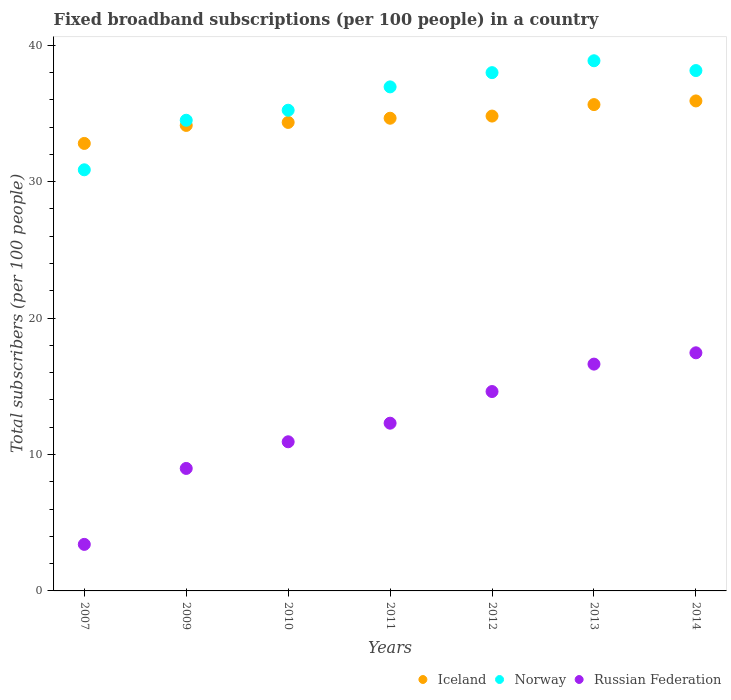What is the number of broadband subscriptions in Russian Federation in 2011?
Make the answer very short. 12.29. Across all years, what is the maximum number of broadband subscriptions in Russian Federation?
Keep it short and to the point. 17.45. Across all years, what is the minimum number of broadband subscriptions in Iceland?
Offer a very short reply. 32.8. In which year was the number of broadband subscriptions in Russian Federation minimum?
Give a very brief answer. 2007. What is the total number of broadband subscriptions in Russian Federation in the graph?
Ensure brevity in your answer.  84.31. What is the difference between the number of broadband subscriptions in Russian Federation in 2011 and that in 2014?
Your answer should be compact. -5.16. What is the difference between the number of broadband subscriptions in Iceland in 2011 and the number of broadband subscriptions in Norway in 2010?
Ensure brevity in your answer.  -0.59. What is the average number of broadband subscriptions in Norway per year?
Your answer should be very brief. 36.08. In the year 2012, what is the difference between the number of broadband subscriptions in Iceland and number of broadband subscriptions in Norway?
Your answer should be very brief. -3.18. In how many years, is the number of broadband subscriptions in Norway greater than 22?
Ensure brevity in your answer.  7. What is the ratio of the number of broadband subscriptions in Iceland in 2010 to that in 2012?
Give a very brief answer. 0.99. What is the difference between the highest and the second highest number of broadband subscriptions in Norway?
Offer a terse response. 0.72. What is the difference between the highest and the lowest number of broadband subscriptions in Russian Federation?
Provide a short and direct response. 14.04. Is the sum of the number of broadband subscriptions in Iceland in 2007 and 2014 greater than the maximum number of broadband subscriptions in Russian Federation across all years?
Offer a very short reply. Yes. Is the number of broadband subscriptions in Iceland strictly greater than the number of broadband subscriptions in Russian Federation over the years?
Your answer should be very brief. Yes. Is the number of broadband subscriptions in Russian Federation strictly less than the number of broadband subscriptions in Iceland over the years?
Provide a short and direct response. Yes. How many dotlines are there?
Provide a short and direct response. 3. What is the difference between two consecutive major ticks on the Y-axis?
Offer a terse response. 10. Does the graph contain grids?
Provide a succinct answer. No. Where does the legend appear in the graph?
Your response must be concise. Bottom right. How many legend labels are there?
Keep it short and to the point. 3. What is the title of the graph?
Keep it short and to the point. Fixed broadband subscriptions (per 100 people) in a country. What is the label or title of the Y-axis?
Offer a very short reply. Total subscribers (per 100 people). What is the Total subscribers (per 100 people) in Iceland in 2007?
Ensure brevity in your answer.  32.8. What is the Total subscribers (per 100 people) of Norway in 2007?
Your response must be concise. 30.87. What is the Total subscribers (per 100 people) of Russian Federation in 2007?
Provide a succinct answer. 3.41. What is the Total subscribers (per 100 people) of Iceland in 2009?
Provide a short and direct response. 34.12. What is the Total subscribers (per 100 people) of Norway in 2009?
Your answer should be compact. 34.5. What is the Total subscribers (per 100 people) of Russian Federation in 2009?
Make the answer very short. 8.98. What is the Total subscribers (per 100 people) in Iceland in 2010?
Your response must be concise. 34.34. What is the Total subscribers (per 100 people) of Norway in 2010?
Ensure brevity in your answer.  35.23. What is the Total subscribers (per 100 people) of Russian Federation in 2010?
Keep it short and to the point. 10.93. What is the Total subscribers (per 100 people) of Iceland in 2011?
Provide a succinct answer. 34.65. What is the Total subscribers (per 100 people) of Norway in 2011?
Keep it short and to the point. 36.94. What is the Total subscribers (per 100 people) of Russian Federation in 2011?
Give a very brief answer. 12.29. What is the Total subscribers (per 100 people) in Iceland in 2012?
Provide a short and direct response. 34.81. What is the Total subscribers (per 100 people) of Norway in 2012?
Give a very brief answer. 37.99. What is the Total subscribers (per 100 people) in Russian Federation in 2012?
Your answer should be compact. 14.61. What is the Total subscribers (per 100 people) of Iceland in 2013?
Offer a terse response. 35.65. What is the Total subscribers (per 100 people) of Norway in 2013?
Provide a succinct answer. 38.86. What is the Total subscribers (per 100 people) of Russian Federation in 2013?
Provide a short and direct response. 16.62. What is the Total subscribers (per 100 people) of Iceland in 2014?
Your answer should be compact. 35.92. What is the Total subscribers (per 100 people) of Norway in 2014?
Your response must be concise. 38.14. What is the Total subscribers (per 100 people) of Russian Federation in 2014?
Provide a succinct answer. 17.45. Across all years, what is the maximum Total subscribers (per 100 people) of Iceland?
Make the answer very short. 35.92. Across all years, what is the maximum Total subscribers (per 100 people) in Norway?
Offer a very short reply. 38.86. Across all years, what is the maximum Total subscribers (per 100 people) of Russian Federation?
Make the answer very short. 17.45. Across all years, what is the minimum Total subscribers (per 100 people) in Iceland?
Your answer should be very brief. 32.8. Across all years, what is the minimum Total subscribers (per 100 people) in Norway?
Your response must be concise. 30.87. Across all years, what is the minimum Total subscribers (per 100 people) of Russian Federation?
Offer a terse response. 3.41. What is the total Total subscribers (per 100 people) of Iceland in the graph?
Your response must be concise. 242.27. What is the total Total subscribers (per 100 people) of Norway in the graph?
Ensure brevity in your answer.  252.53. What is the total Total subscribers (per 100 people) in Russian Federation in the graph?
Your response must be concise. 84.31. What is the difference between the Total subscribers (per 100 people) in Iceland in 2007 and that in 2009?
Give a very brief answer. -1.32. What is the difference between the Total subscribers (per 100 people) in Norway in 2007 and that in 2009?
Your answer should be very brief. -3.63. What is the difference between the Total subscribers (per 100 people) of Russian Federation in 2007 and that in 2009?
Give a very brief answer. -5.57. What is the difference between the Total subscribers (per 100 people) of Iceland in 2007 and that in 2010?
Make the answer very short. -1.54. What is the difference between the Total subscribers (per 100 people) of Norway in 2007 and that in 2010?
Your answer should be very brief. -4.37. What is the difference between the Total subscribers (per 100 people) of Russian Federation in 2007 and that in 2010?
Your response must be concise. -7.52. What is the difference between the Total subscribers (per 100 people) of Iceland in 2007 and that in 2011?
Provide a short and direct response. -1.85. What is the difference between the Total subscribers (per 100 people) in Norway in 2007 and that in 2011?
Give a very brief answer. -6.08. What is the difference between the Total subscribers (per 100 people) in Russian Federation in 2007 and that in 2011?
Give a very brief answer. -8.88. What is the difference between the Total subscribers (per 100 people) of Iceland in 2007 and that in 2012?
Ensure brevity in your answer.  -2.01. What is the difference between the Total subscribers (per 100 people) of Norway in 2007 and that in 2012?
Provide a short and direct response. -7.12. What is the difference between the Total subscribers (per 100 people) in Russian Federation in 2007 and that in 2012?
Provide a succinct answer. -11.2. What is the difference between the Total subscribers (per 100 people) of Iceland in 2007 and that in 2013?
Keep it short and to the point. -2.85. What is the difference between the Total subscribers (per 100 people) of Norway in 2007 and that in 2013?
Provide a short and direct response. -7.99. What is the difference between the Total subscribers (per 100 people) in Russian Federation in 2007 and that in 2013?
Your answer should be very brief. -13.21. What is the difference between the Total subscribers (per 100 people) in Iceland in 2007 and that in 2014?
Offer a terse response. -3.12. What is the difference between the Total subscribers (per 100 people) in Norway in 2007 and that in 2014?
Keep it short and to the point. -7.27. What is the difference between the Total subscribers (per 100 people) of Russian Federation in 2007 and that in 2014?
Your answer should be very brief. -14.04. What is the difference between the Total subscribers (per 100 people) in Iceland in 2009 and that in 2010?
Your response must be concise. -0.22. What is the difference between the Total subscribers (per 100 people) of Norway in 2009 and that in 2010?
Provide a succinct answer. -0.73. What is the difference between the Total subscribers (per 100 people) in Russian Federation in 2009 and that in 2010?
Provide a succinct answer. -1.95. What is the difference between the Total subscribers (per 100 people) of Iceland in 2009 and that in 2011?
Your response must be concise. -0.53. What is the difference between the Total subscribers (per 100 people) in Norway in 2009 and that in 2011?
Make the answer very short. -2.45. What is the difference between the Total subscribers (per 100 people) in Russian Federation in 2009 and that in 2011?
Offer a very short reply. -3.32. What is the difference between the Total subscribers (per 100 people) in Iceland in 2009 and that in 2012?
Offer a terse response. -0.68. What is the difference between the Total subscribers (per 100 people) of Norway in 2009 and that in 2012?
Your response must be concise. -3.49. What is the difference between the Total subscribers (per 100 people) in Russian Federation in 2009 and that in 2012?
Your answer should be compact. -5.64. What is the difference between the Total subscribers (per 100 people) of Iceland in 2009 and that in 2013?
Your answer should be very brief. -1.53. What is the difference between the Total subscribers (per 100 people) of Norway in 2009 and that in 2013?
Ensure brevity in your answer.  -4.36. What is the difference between the Total subscribers (per 100 people) in Russian Federation in 2009 and that in 2013?
Provide a succinct answer. -7.65. What is the difference between the Total subscribers (per 100 people) of Iceland in 2009 and that in 2014?
Ensure brevity in your answer.  -1.79. What is the difference between the Total subscribers (per 100 people) in Norway in 2009 and that in 2014?
Offer a terse response. -3.64. What is the difference between the Total subscribers (per 100 people) in Russian Federation in 2009 and that in 2014?
Give a very brief answer. -8.48. What is the difference between the Total subscribers (per 100 people) of Iceland in 2010 and that in 2011?
Offer a very short reply. -0.31. What is the difference between the Total subscribers (per 100 people) of Norway in 2010 and that in 2011?
Make the answer very short. -1.71. What is the difference between the Total subscribers (per 100 people) of Russian Federation in 2010 and that in 2011?
Provide a short and direct response. -1.36. What is the difference between the Total subscribers (per 100 people) in Iceland in 2010 and that in 2012?
Make the answer very short. -0.47. What is the difference between the Total subscribers (per 100 people) of Norway in 2010 and that in 2012?
Your answer should be compact. -2.75. What is the difference between the Total subscribers (per 100 people) of Russian Federation in 2010 and that in 2012?
Give a very brief answer. -3.68. What is the difference between the Total subscribers (per 100 people) of Iceland in 2010 and that in 2013?
Your answer should be compact. -1.31. What is the difference between the Total subscribers (per 100 people) in Norway in 2010 and that in 2013?
Make the answer very short. -3.63. What is the difference between the Total subscribers (per 100 people) in Russian Federation in 2010 and that in 2013?
Your answer should be very brief. -5.69. What is the difference between the Total subscribers (per 100 people) of Iceland in 2010 and that in 2014?
Provide a short and direct response. -1.58. What is the difference between the Total subscribers (per 100 people) of Norway in 2010 and that in 2014?
Provide a short and direct response. -2.91. What is the difference between the Total subscribers (per 100 people) of Russian Federation in 2010 and that in 2014?
Keep it short and to the point. -6.52. What is the difference between the Total subscribers (per 100 people) in Iceland in 2011 and that in 2012?
Provide a short and direct response. -0.16. What is the difference between the Total subscribers (per 100 people) of Norway in 2011 and that in 2012?
Keep it short and to the point. -1.04. What is the difference between the Total subscribers (per 100 people) of Russian Federation in 2011 and that in 2012?
Offer a very short reply. -2.32. What is the difference between the Total subscribers (per 100 people) in Iceland in 2011 and that in 2013?
Your response must be concise. -1. What is the difference between the Total subscribers (per 100 people) of Norway in 2011 and that in 2013?
Your response must be concise. -1.92. What is the difference between the Total subscribers (per 100 people) of Russian Federation in 2011 and that in 2013?
Your answer should be very brief. -4.33. What is the difference between the Total subscribers (per 100 people) in Iceland in 2011 and that in 2014?
Your answer should be compact. -1.27. What is the difference between the Total subscribers (per 100 people) in Norway in 2011 and that in 2014?
Provide a succinct answer. -1.2. What is the difference between the Total subscribers (per 100 people) of Russian Federation in 2011 and that in 2014?
Offer a terse response. -5.16. What is the difference between the Total subscribers (per 100 people) of Iceland in 2012 and that in 2013?
Provide a short and direct response. -0.84. What is the difference between the Total subscribers (per 100 people) in Norway in 2012 and that in 2013?
Keep it short and to the point. -0.87. What is the difference between the Total subscribers (per 100 people) in Russian Federation in 2012 and that in 2013?
Offer a very short reply. -2.01. What is the difference between the Total subscribers (per 100 people) in Iceland in 2012 and that in 2014?
Provide a succinct answer. -1.11. What is the difference between the Total subscribers (per 100 people) in Norway in 2012 and that in 2014?
Offer a terse response. -0.15. What is the difference between the Total subscribers (per 100 people) in Russian Federation in 2012 and that in 2014?
Ensure brevity in your answer.  -2.84. What is the difference between the Total subscribers (per 100 people) of Iceland in 2013 and that in 2014?
Your answer should be very brief. -0.27. What is the difference between the Total subscribers (per 100 people) of Norway in 2013 and that in 2014?
Ensure brevity in your answer.  0.72. What is the difference between the Total subscribers (per 100 people) in Russian Federation in 2013 and that in 2014?
Keep it short and to the point. -0.83. What is the difference between the Total subscribers (per 100 people) in Iceland in 2007 and the Total subscribers (per 100 people) in Norway in 2009?
Your answer should be compact. -1.7. What is the difference between the Total subscribers (per 100 people) in Iceland in 2007 and the Total subscribers (per 100 people) in Russian Federation in 2009?
Make the answer very short. 23.82. What is the difference between the Total subscribers (per 100 people) of Norway in 2007 and the Total subscribers (per 100 people) of Russian Federation in 2009?
Offer a terse response. 21.89. What is the difference between the Total subscribers (per 100 people) in Iceland in 2007 and the Total subscribers (per 100 people) in Norway in 2010?
Your response must be concise. -2.43. What is the difference between the Total subscribers (per 100 people) in Iceland in 2007 and the Total subscribers (per 100 people) in Russian Federation in 2010?
Ensure brevity in your answer.  21.87. What is the difference between the Total subscribers (per 100 people) in Norway in 2007 and the Total subscribers (per 100 people) in Russian Federation in 2010?
Offer a very short reply. 19.94. What is the difference between the Total subscribers (per 100 people) in Iceland in 2007 and the Total subscribers (per 100 people) in Norway in 2011?
Ensure brevity in your answer.  -4.14. What is the difference between the Total subscribers (per 100 people) in Iceland in 2007 and the Total subscribers (per 100 people) in Russian Federation in 2011?
Make the answer very short. 20.51. What is the difference between the Total subscribers (per 100 people) of Norway in 2007 and the Total subscribers (per 100 people) of Russian Federation in 2011?
Offer a terse response. 18.57. What is the difference between the Total subscribers (per 100 people) of Iceland in 2007 and the Total subscribers (per 100 people) of Norway in 2012?
Your answer should be very brief. -5.19. What is the difference between the Total subscribers (per 100 people) in Iceland in 2007 and the Total subscribers (per 100 people) in Russian Federation in 2012?
Provide a short and direct response. 18.19. What is the difference between the Total subscribers (per 100 people) of Norway in 2007 and the Total subscribers (per 100 people) of Russian Federation in 2012?
Offer a terse response. 16.25. What is the difference between the Total subscribers (per 100 people) in Iceland in 2007 and the Total subscribers (per 100 people) in Norway in 2013?
Make the answer very short. -6.06. What is the difference between the Total subscribers (per 100 people) in Iceland in 2007 and the Total subscribers (per 100 people) in Russian Federation in 2013?
Offer a very short reply. 16.18. What is the difference between the Total subscribers (per 100 people) of Norway in 2007 and the Total subscribers (per 100 people) of Russian Federation in 2013?
Your response must be concise. 14.24. What is the difference between the Total subscribers (per 100 people) of Iceland in 2007 and the Total subscribers (per 100 people) of Norway in 2014?
Offer a very short reply. -5.34. What is the difference between the Total subscribers (per 100 people) in Iceland in 2007 and the Total subscribers (per 100 people) in Russian Federation in 2014?
Offer a terse response. 15.35. What is the difference between the Total subscribers (per 100 people) of Norway in 2007 and the Total subscribers (per 100 people) of Russian Federation in 2014?
Ensure brevity in your answer.  13.41. What is the difference between the Total subscribers (per 100 people) in Iceland in 2009 and the Total subscribers (per 100 people) in Norway in 2010?
Make the answer very short. -1.11. What is the difference between the Total subscribers (per 100 people) of Iceland in 2009 and the Total subscribers (per 100 people) of Russian Federation in 2010?
Provide a short and direct response. 23.19. What is the difference between the Total subscribers (per 100 people) in Norway in 2009 and the Total subscribers (per 100 people) in Russian Federation in 2010?
Provide a short and direct response. 23.57. What is the difference between the Total subscribers (per 100 people) in Iceland in 2009 and the Total subscribers (per 100 people) in Norway in 2011?
Offer a very short reply. -2.82. What is the difference between the Total subscribers (per 100 people) in Iceland in 2009 and the Total subscribers (per 100 people) in Russian Federation in 2011?
Your answer should be very brief. 21.83. What is the difference between the Total subscribers (per 100 people) of Norway in 2009 and the Total subscribers (per 100 people) of Russian Federation in 2011?
Keep it short and to the point. 22.2. What is the difference between the Total subscribers (per 100 people) in Iceland in 2009 and the Total subscribers (per 100 people) in Norway in 2012?
Offer a very short reply. -3.87. What is the difference between the Total subscribers (per 100 people) of Iceland in 2009 and the Total subscribers (per 100 people) of Russian Federation in 2012?
Your answer should be very brief. 19.51. What is the difference between the Total subscribers (per 100 people) of Norway in 2009 and the Total subscribers (per 100 people) of Russian Federation in 2012?
Give a very brief answer. 19.88. What is the difference between the Total subscribers (per 100 people) of Iceland in 2009 and the Total subscribers (per 100 people) of Norway in 2013?
Your answer should be very brief. -4.74. What is the difference between the Total subscribers (per 100 people) of Iceland in 2009 and the Total subscribers (per 100 people) of Russian Federation in 2013?
Keep it short and to the point. 17.5. What is the difference between the Total subscribers (per 100 people) of Norway in 2009 and the Total subscribers (per 100 people) of Russian Federation in 2013?
Ensure brevity in your answer.  17.87. What is the difference between the Total subscribers (per 100 people) of Iceland in 2009 and the Total subscribers (per 100 people) of Norway in 2014?
Your answer should be compact. -4.02. What is the difference between the Total subscribers (per 100 people) of Iceland in 2009 and the Total subscribers (per 100 people) of Russian Federation in 2014?
Offer a very short reply. 16.67. What is the difference between the Total subscribers (per 100 people) of Norway in 2009 and the Total subscribers (per 100 people) of Russian Federation in 2014?
Your answer should be compact. 17.05. What is the difference between the Total subscribers (per 100 people) of Iceland in 2010 and the Total subscribers (per 100 people) of Norway in 2011?
Ensure brevity in your answer.  -2.61. What is the difference between the Total subscribers (per 100 people) of Iceland in 2010 and the Total subscribers (per 100 people) of Russian Federation in 2011?
Give a very brief answer. 22.04. What is the difference between the Total subscribers (per 100 people) of Norway in 2010 and the Total subscribers (per 100 people) of Russian Federation in 2011?
Your answer should be compact. 22.94. What is the difference between the Total subscribers (per 100 people) of Iceland in 2010 and the Total subscribers (per 100 people) of Norway in 2012?
Provide a short and direct response. -3.65. What is the difference between the Total subscribers (per 100 people) in Iceland in 2010 and the Total subscribers (per 100 people) in Russian Federation in 2012?
Give a very brief answer. 19.72. What is the difference between the Total subscribers (per 100 people) of Norway in 2010 and the Total subscribers (per 100 people) of Russian Federation in 2012?
Make the answer very short. 20.62. What is the difference between the Total subscribers (per 100 people) in Iceland in 2010 and the Total subscribers (per 100 people) in Norway in 2013?
Provide a succinct answer. -4.52. What is the difference between the Total subscribers (per 100 people) of Iceland in 2010 and the Total subscribers (per 100 people) of Russian Federation in 2013?
Provide a succinct answer. 17.71. What is the difference between the Total subscribers (per 100 people) in Norway in 2010 and the Total subscribers (per 100 people) in Russian Federation in 2013?
Offer a terse response. 18.61. What is the difference between the Total subscribers (per 100 people) in Iceland in 2010 and the Total subscribers (per 100 people) in Norway in 2014?
Give a very brief answer. -3.8. What is the difference between the Total subscribers (per 100 people) of Iceland in 2010 and the Total subscribers (per 100 people) of Russian Federation in 2014?
Ensure brevity in your answer.  16.89. What is the difference between the Total subscribers (per 100 people) of Norway in 2010 and the Total subscribers (per 100 people) of Russian Federation in 2014?
Keep it short and to the point. 17.78. What is the difference between the Total subscribers (per 100 people) in Iceland in 2011 and the Total subscribers (per 100 people) in Norway in 2012?
Your response must be concise. -3.34. What is the difference between the Total subscribers (per 100 people) of Iceland in 2011 and the Total subscribers (per 100 people) of Russian Federation in 2012?
Offer a very short reply. 20.03. What is the difference between the Total subscribers (per 100 people) of Norway in 2011 and the Total subscribers (per 100 people) of Russian Federation in 2012?
Your answer should be very brief. 22.33. What is the difference between the Total subscribers (per 100 people) of Iceland in 2011 and the Total subscribers (per 100 people) of Norway in 2013?
Ensure brevity in your answer.  -4.21. What is the difference between the Total subscribers (per 100 people) of Iceland in 2011 and the Total subscribers (per 100 people) of Russian Federation in 2013?
Offer a terse response. 18.02. What is the difference between the Total subscribers (per 100 people) in Norway in 2011 and the Total subscribers (per 100 people) in Russian Federation in 2013?
Give a very brief answer. 20.32. What is the difference between the Total subscribers (per 100 people) of Iceland in 2011 and the Total subscribers (per 100 people) of Norway in 2014?
Offer a very short reply. -3.49. What is the difference between the Total subscribers (per 100 people) of Iceland in 2011 and the Total subscribers (per 100 people) of Russian Federation in 2014?
Provide a succinct answer. 17.19. What is the difference between the Total subscribers (per 100 people) of Norway in 2011 and the Total subscribers (per 100 people) of Russian Federation in 2014?
Offer a very short reply. 19.49. What is the difference between the Total subscribers (per 100 people) of Iceland in 2012 and the Total subscribers (per 100 people) of Norway in 2013?
Your answer should be compact. -4.05. What is the difference between the Total subscribers (per 100 people) in Iceland in 2012 and the Total subscribers (per 100 people) in Russian Federation in 2013?
Provide a succinct answer. 18.18. What is the difference between the Total subscribers (per 100 people) of Norway in 2012 and the Total subscribers (per 100 people) of Russian Federation in 2013?
Ensure brevity in your answer.  21.36. What is the difference between the Total subscribers (per 100 people) in Iceland in 2012 and the Total subscribers (per 100 people) in Norway in 2014?
Your answer should be compact. -3.34. What is the difference between the Total subscribers (per 100 people) of Iceland in 2012 and the Total subscribers (per 100 people) of Russian Federation in 2014?
Offer a very short reply. 17.35. What is the difference between the Total subscribers (per 100 people) in Norway in 2012 and the Total subscribers (per 100 people) in Russian Federation in 2014?
Your answer should be compact. 20.54. What is the difference between the Total subscribers (per 100 people) in Iceland in 2013 and the Total subscribers (per 100 people) in Norway in 2014?
Offer a very short reply. -2.5. What is the difference between the Total subscribers (per 100 people) in Iceland in 2013 and the Total subscribers (per 100 people) in Russian Federation in 2014?
Keep it short and to the point. 18.19. What is the difference between the Total subscribers (per 100 people) of Norway in 2013 and the Total subscribers (per 100 people) of Russian Federation in 2014?
Your answer should be very brief. 21.41. What is the average Total subscribers (per 100 people) of Iceland per year?
Give a very brief answer. 34.61. What is the average Total subscribers (per 100 people) of Norway per year?
Ensure brevity in your answer.  36.08. What is the average Total subscribers (per 100 people) in Russian Federation per year?
Provide a short and direct response. 12.04. In the year 2007, what is the difference between the Total subscribers (per 100 people) in Iceland and Total subscribers (per 100 people) in Norway?
Keep it short and to the point. 1.93. In the year 2007, what is the difference between the Total subscribers (per 100 people) of Iceland and Total subscribers (per 100 people) of Russian Federation?
Make the answer very short. 29.39. In the year 2007, what is the difference between the Total subscribers (per 100 people) in Norway and Total subscribers (per 100 people) in Russian Federation?
Give a very brief answer. 27.46. In the year 2009, what is the difference between the Total subscribers (per 100 people) in Iceland and Total subscribers (per 100 people) in Norway?
Provide a short and direct response. -0.38. In the year 2009, what is the difference between the Total subscribers (per 100 people) in Iceland and Total subscribers (per 100 people) in Russian Federation?
Ensure brevity in your answer.  25.14. In the year 2009, what is the difference between the Total subscribers (per 100 people) in Norway and Total subscribers (per 100 people) in Russian Federation?
Your answer should be compact. 25.52. In the year 2010, what is the difference between the Total subscribers (per 100 people) of Iceland and Total subscribers (per 100 people) of Norway?
Your answer should be compact. -0.89. In the year 2010, what is the difference between the Total subscribers (per 100 people) in Iceland and Total subscribers (per 100 people) in Russian Federation?
Offer a very short reply. 23.41. In the year 2010, what is the difference between the Total subscribers (per 100 people) of Norway and Total subscribers (per 100 people) of Russian Federation?
Your response must be concise. 24.3. In the year 2011, what is the difference between the Total subscribers (per 100 people) in Iceland and Total subscribers (per 100 people) in Norway?
Offer a terse response. -2.3. In the year 2011, what is the difference between the Total subscribers (per 100 people) of Iceland and Total subscribers (per 100 people) of Russian Federation?
Keep it short and to the point. 22.35. In the year 2011, what is the difference between the Total subscribers (per 100 people) of Norway and Total subscribers (per 100 people) of Russian Federation?
Provide a succinct answer. 24.65. In the year 2012, what is the difference between the Total subscribers (per 100 people) of Iceland and Total subscribers (per 100 people) of Norway?
Your answer should be very brief. -3.18. In the year 2012, what is the difference between the Total subscribers (per 100 people) in Iceland and Total subscribers (per 100 people) in Russian Federation?
Keep it short and to the point. 20.19. In the year 2012, what is the difference between the Total subscribers (per 100 people) in Norway and Total subscribers (per 100 people) in Russian Federation?
Provide a succinct answer. 23.37. In the year 2013, what is the difference between the Total subscribers (per 100 people) in Iceland and Total subscribers (per 100 people) in Norway?
Keep it short and to the point. -3.21. In the year 2013, what is the difference between the Total subscribers (per 100 people) of Iceland and Total subscribers (per 100 people) of Russian Federation?
Give a very brief answer. 19.02. In the year 2013, what is the difference between the Total subscribers (per 100 people) of Norway and Total subscribers (per 100 people) of Russian Federation?
Ensure brevity in your answer.  22.24. In the year 2014, what is the difference between the Total subscribers (per 100 people) of Iceland and Total subscribers (per 100 people) of Norway?
Offer a terse response. -2.23. In the year 2014, what is the difference between the Total subscribers (per 100 people) in Iceland and Total subscribers (per 100 people) in Russian Federation?
Provide a short and direct response. 18.46. In the year 2014, what is the difference between the Total subscribers (per 100 people) of Norway and Total subscribers (per 100 people) of Russian Federation?
Provide a short and direct response. 20.69. What is the ratio of the Total subscribers (per 100 people) of Iceland in 2007 to that in 2009?
Offer a very short reply. 0.96. What is the ratio of the Total subscribers (per 100 people) in Norway in 2007 to that in 2009?
Your answer should be compact. 0.89. What is the ratio of the Total subscribers (per 100 people) in Russian Federation in 2007 to that in 2009?
Your answer should be very brief. 0.38. What is the ratio of the Total subscribers (per 100 people) in Iceland in 2007 to that in 2010?
Your response must be concise. 0.96. What is the ratio of the Total subscribers (per 100 people) in Norway in 2007 to that in 2010?
Your answer should be compact. 0.88. What is the ratio of the Total subscribers (per 100 people) of Russian Federation in 2007 to that in 2010?
Your answer should be compact. 0.31. What is the ratio of the Total subscribers (per 100 people) of Iceland in 2007 to that in 2011?
Your response must be concise. 0.95. What is the ratio of the Total subscribers (per 100 people) of Norway in 2007 to that in 2011?
Your answer should be very brief. 0.84. What is the ratio of the Total subscribers (per 100 people) of Russian Federation in 2007 to that in 2011?
Give a very brief answer. 0.28. What is the ratio of the Total subscribers (per 100 people) in Iceland in 2007 to that in 2012?
Your response must be concise. 0.94. What is the ratio of the Total subscribers (per 100 people) in Norway in 2007 to that in 2012?
Ensure brevity in your answer.  0.81. What is the ratio of the Total subscribers (per 100 people) of Russian Federation in 2007 to that in 2012?
Make the answer very short. 0.23. What is the ratio of the Total subscribers (per 100 people) of Iceland in 2007 to that in 2013?
Keep it short and to the point. 0.92. What is the ratio of the Total subscribers (per 100 people) in Norway in 2007 to that in 2013?
Your answer should be compact. 0.79. What is the ratio of the Total subscribers (per 100 people) of Russian Federation in 2007 to that in 2013?
Give a very brief answer. 0.21. What is the ratio of the Total subscribers (per 100 people) in Iceland in 2007 to that in 2014?
Provide a short and direct response. 0.91. What is the ratio of the Total subscribers (per 100 people) of Norway in 2007 to that in 2014?
Give a very brief answer. 0.81. What is the ratio of the Total subscribers (per 100 people) of Russian Federation in 2007 to that in 2014?
Give a very brief answer. 0.2. What is the ratio of the Total subscribers (per 100 people) in Norway in 2009 to that in 2010?
Make the answer very short. 0.98. What is the ratio of the Total subscribers (per 100 people) of Russian Federation in 2009 to that in 2010?
Give a very brief answer. 0.82. What is the ratio of the Total subscribers (per 100 people) of Norway in 2009 to that in 2011?
Provide a short and direct response. 0.93. What is the ratio of the Total subscribers (per 100 people) in Russian Federation in 2009 to that in 2011?
Provide a short and direct response. 0.73. What is the ratio of the Total subscribers (per 100 people) of Iceland in 2009 to that in 2012?
Ensure brevity in your answer.  0.98. What is the ratio of the Total subscribers (per 100 people) in Norway in 2009 to that in 2012?
Offer a terse response. 0.91. What is the ratio of the Total subscribers (per 100 people) of Russian Federation in 2009 to that in 2012?
Your answer should be compact. 0.61. What is the ratio of the Total subscribers (per 100 people) of Iceland in 2009 to that in 2013?
Provide a succinct answer. 0.96. What is the ratio of the Total subscribers (per 100 people) in Norway in 2009 to that in 2013?
Ensure brevity in your answer.  0.89. What is the ratio of the Total subscribers (per 100 people) of Russian Federation in 2009 to that in 2013?
Make the answer very short. 0.54. What is the ratio of the Total subscribers (per 100 people) in Norway in 2009 to that in 2014?
Provide a succinct answer. 0.9. What is the ratio of the Total subscribers (per 100 people) of Russian Federation in 2009 to that in 2014?
Provide a short and direct response. 0.51. What is the ratio of the Total subscribers (per 100 people) in Iceland in 2010 to that in 2011?
Provide a succinct answer. 0.99. What is the ratio of the Total subscribers (per 100 people) of Norway in 2010 to that in 2011?
Make the answer very short. 0.95. What is the ratio of the Total subscribers (per 100 people) of Russian Federation in 2010 to that in 2011?
Keep it short and to the point. 0.89. What is the ratio of the Total subscribers (per 100 people) of Iceland in 2010 to that in 2012?
Make the answer very short. 0.99. What is the ratio of the Total subscribers (per 100 people) of Norway in 2010 to that in 2012?
Keep it short and to the point. 0.93. What is the ratio of the Total subscribers (per 100 people) of Russian Federation in 2010 to that in 2012?
Your response must be concise. 0.75. What is the ratio of the Total subscribers (per 100 people) in Iceland in 2010 to that in 2013?
Ensure brevity in your answer.  0.96. What is the ratio of the Total subscribers (per 100 people) in Norway in 2010 to that in 2013?
Make the answer very short. 0.91. What is the ratio of the Total subscribers (per 100 people) of Russian Federation in 2010 to that in 2013?
Your response must be concise. 0.66. What is the ratio of the Total subscribers (per 100 people) of Iceland in 2010 to that in 2014?
Give a very brief answer. 0.96. What is the ratio of the Total subscribers (per 100 people) in Norway in 2010 to that in 2014?
Make the answer very short. 0.92. What is the ratio of the Total subscribers (per 100 people) in Russian Federation in 2010 to that in 2014?
Provide a short and direct response. 0.63. What is the ratio of the Total subscribers (per 100 people) in Norway in 2011 to that in 2012?
Ensure brevity in your answer.  0.97. What is the ratio of the Total subscribers (per 100 people) in Russian Federation in 2011 to that in 2012?
Your response must be concise. 0.84. What is the ratio of the Total subscribers (per 100 people) of Norway in 2011 to that in 2013?
Your response must be concise. 0.95. What is the ratio of the Total subscribers (per 100 people) in Russian Federation in 2011 to that in 2013?
Ensure brevity in your answer.  0.74. What is the ratio of the Total subscribers (per 100 people) of Iceland in 2011 to that in 2014?
Offer a very short reply. 0.96. What is the ratio of the Total subscribers (per 100 people) in Norway in 2011 to that in 2014?
Provide a short and direct response. 0.97. What is the ratio of the Total subscribers (per 100 people) of Russian Federation in 2011 to that in 2014?
Offer a very short reply. 0.7. What is the ratio of the Total subscribers (per 100 people) in Iceland in 2012 to that in 2013?
Keep it short and to the point. 0.98. What is the ratio of the Total subscribers (per 100 people) in Norway in 2012 to that in 2013?
Offer a very short reply. 0.98. What is the ratio of the Total subscribers (per 100 people) in Russian Federation in 2012 to that in 2013?
Give a very brief answer. 0.88. What is the ratio of the Total subscribers (per 100 people) in Iceland in 2012 to that in 2014?
Make the answer very short. 0.97. What is the ratio of the Total subscribers (per 100 people) in Russian Federation in 2012 to that in 2014?
Your answer should be very brief. 0.84. What is the ratio of the Total subscribers (per 100 people) in Norway in 2013 to that in 2014?
Keep it short and to the point. 1.02. What is the ratio of the Total subscribers (per 100 people) of Russian Federation in 2013 to that in 2014?
Provide a succinct answer. 0.95. What is the difference between the highest and the second highest Total subscribers (per 100 people) in Iceland?
Make the answer very short. 0.27. What is the difference between the highest and the second highest Total subscribers (per 100 people) in Norway?
Your response must be concise. 0.72. What is the difference between the highest and the second highest Total subscribers (per 100 people) of Russian Federation?
Offer a very short reply. 0.83. What is the difference between the highest and the lowest Total subscribers (per 100 people) of Iceland?
Offer a terse response. 3.12. What is the difference between the highest and the lowest Total subscribers (per 100 people) in Norway?
Keep it short and to the point. 7.99. What is the difference between the highest and the lowest Total subscribers (per 100 people) in Russian Federation?
Your answer should be compact. 14.04. 